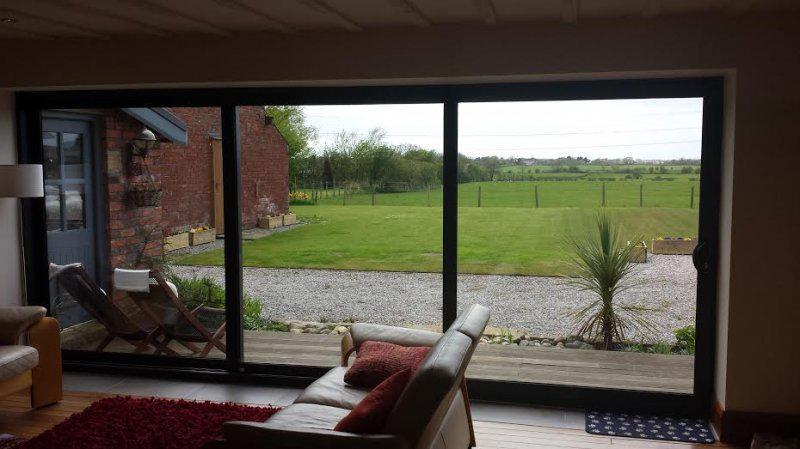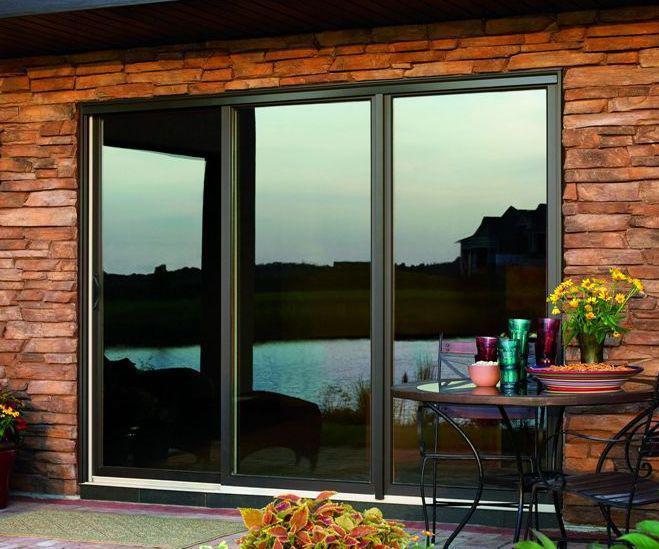The first image is the image on the left, the second image is the image on the right. For the images displayed, is the sentence "Three equal size segments make up each glass door and window panel installation with discreet door hardware visible on one panel." factually correct? Answer yes or no. Yes. 